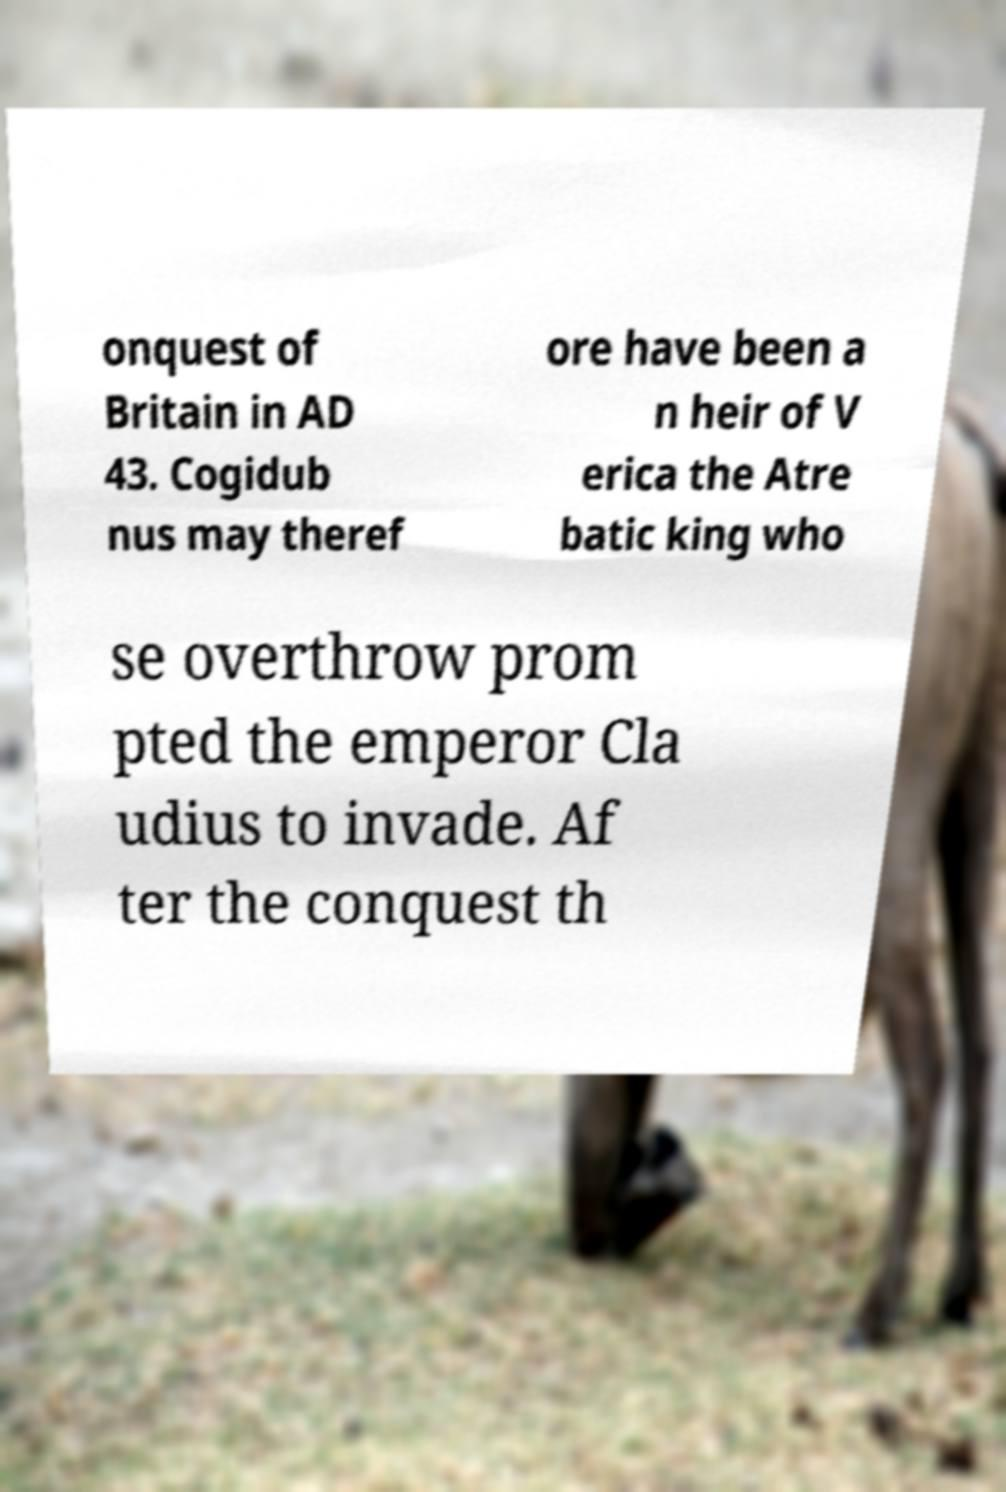I need the written content from this picture converted into text. Can you do that? onquest of Britain in AD 43. Cogidub nus may theref ore have been a n heir of V erica the Atre batic king who se overthrow prom pted the emperor Cla udius to invade. Af ter the conquest th 